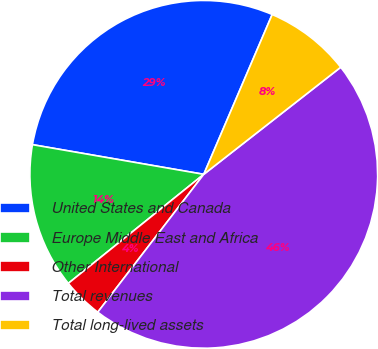<chart> <loc_0><loc_0><loc_500><loc_500><pie_chart><fcel>United States and Canada<fcel>Europe Middle East and Africa<fcel>Other International<fcel>Total revenues<fcel>Total long-lived assets<nl><fcel>28.71%<fcel>13.52%<fcel>3.78%<fcel>46.0%<fcel>8.0%<nl></chart> 